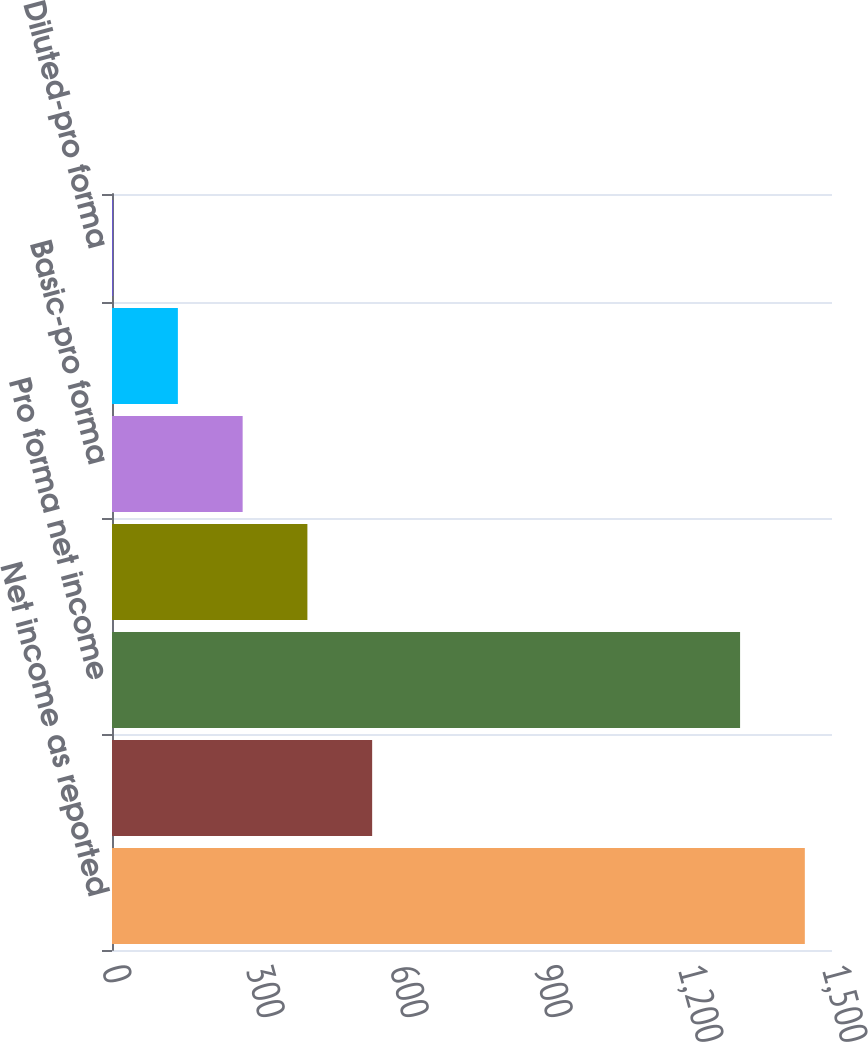Convert chart to OTSL. <chart><loc_0><loc_0><loc_500><loc_500><bar_chart><fcel>Net income as reported<fcel>Less pro forma stock option<fcel>Pro forma net income<fcel>Basic-as reported<fcel>Basic-pro forma<fcel>Diluted-as reported<fcel>Diluted-pro forma<nl><fcel>1443.4<fcel>541.99<fcel>1308.5<fcel>407.08<fcel>272.17<fcel>137.26<fcel>2.35<nl></chart> 